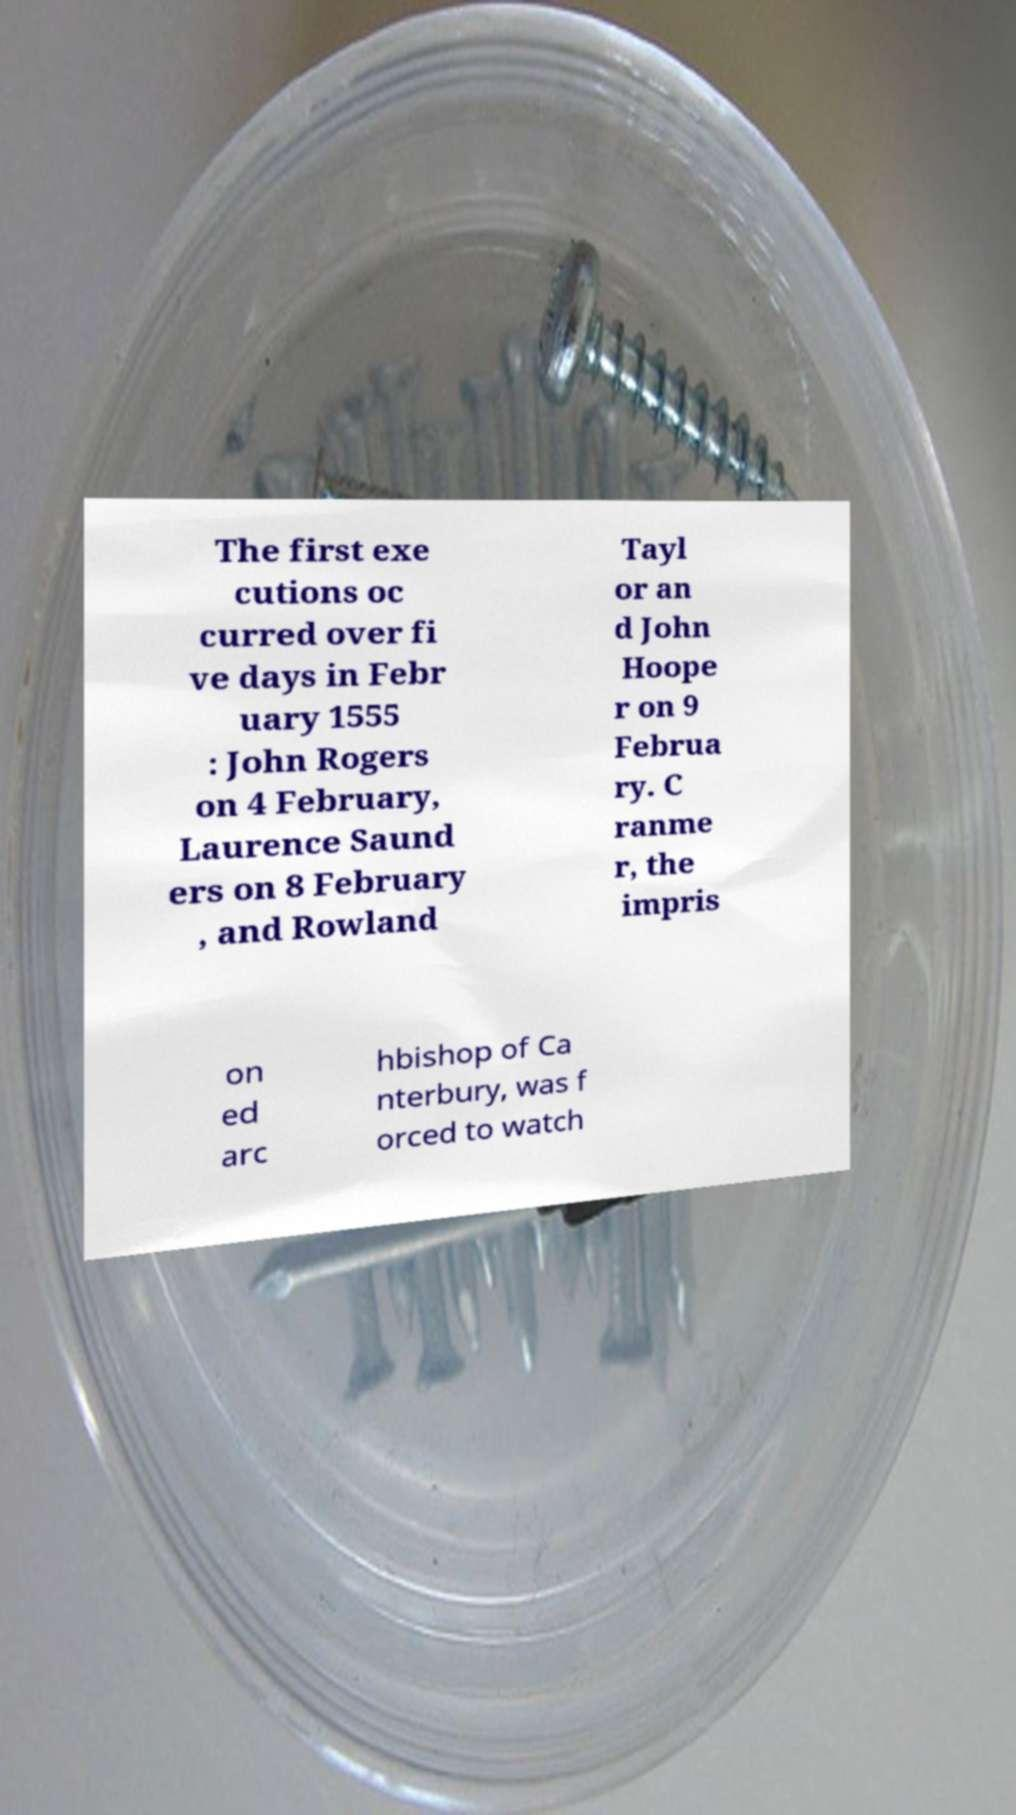I need the written content from this picture converted into text. Can you do that? The first exe cutions oc curred over fi ve days in Febr uary 1555 : John Rogers on 4 February, Laurence Saund ers on 8 February , and Rowland Tayl or an d John Hoope r on 9 Februa ry. C ranme r, the impris on ed arc hbishop of Ca nterbury, was f orced to watch 